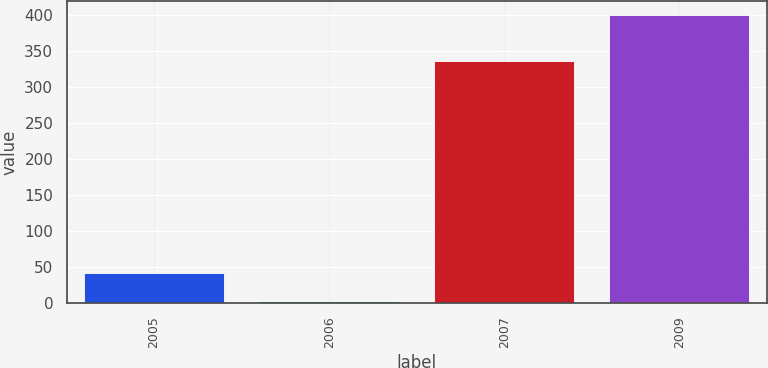Convert chart to OTSL. <chart><loc_0><loc_0><loc_500><loc_500><bar_chart><fcel>2005<fcel>2006<fcel>2007<fcel>2009<nl><fcel>42.7<fcel>3<fcel>336<fcel>400<nl></chart> 